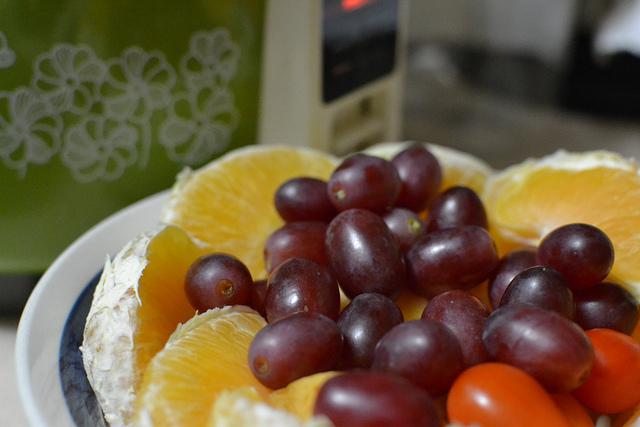Is there a phrase related to this?
Write a very short answer. No. What is the round thing?
Answer briefly. Grape. Is this a lot of fruit?
Answer briefly. Yes. How many grapes are there?
Answer briefly. 21. Which fruit has a visible stem?
Answer briefly. Grape. What kinds of fruit are in the fruit bowl?
Be succinct. Grapes and oranges. Have the oranges been peeled?
Answer briefly. Yes. What kind of fruit is in the bowl?
Concise answer only. Grapes. What colors are the fruit?
Write a very short answer. Purple, orange. Is this picture showing 2 apples and 2 oranges?
Short answer required. No. Are these vegetables?
Concise answer only. No. Is this food good for a typical breakfast?
Give a very brief answer. Yes. What is the name of the purple fruit?
Short answer required. Grape. What is the pattern of the background?
Write a very short answer. Flowers. 